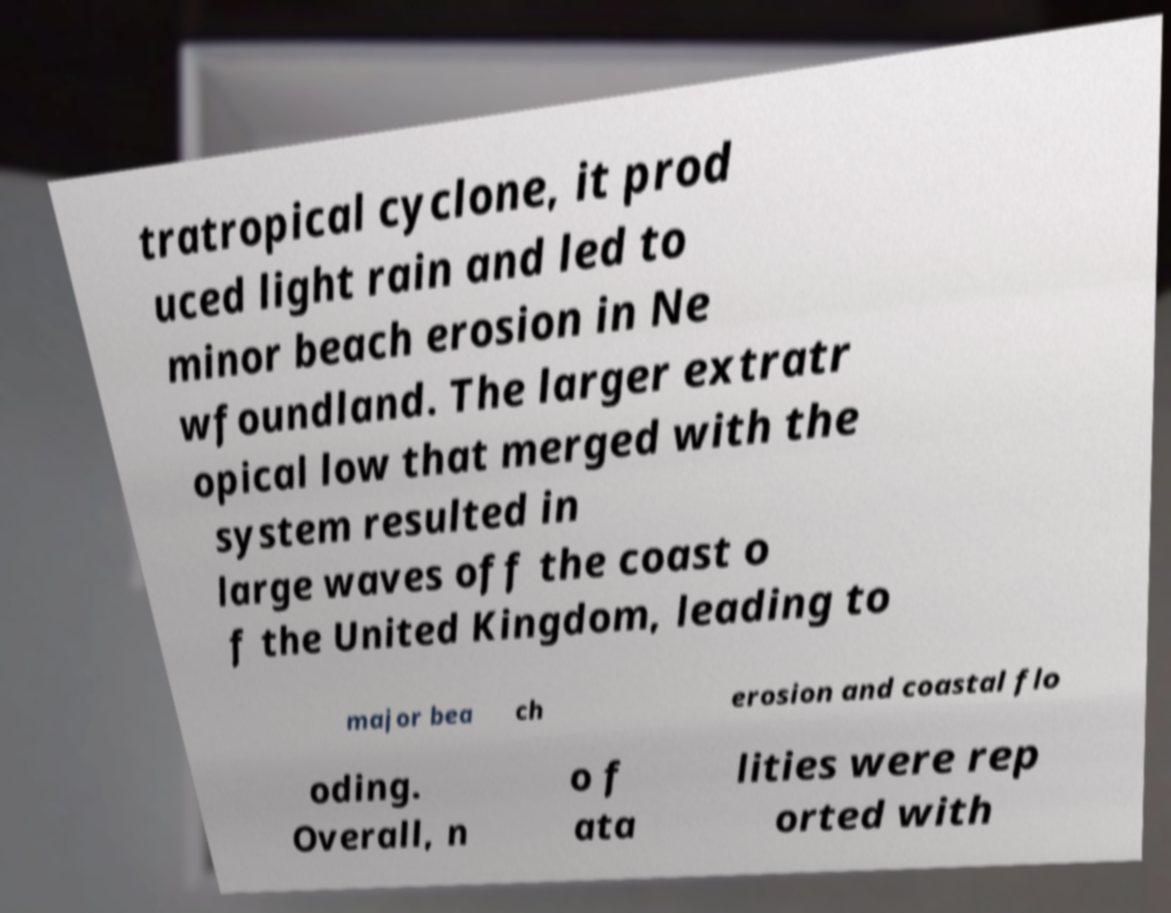Can you accurately transcribe the text from the provided image for me? tratropical cyclone, it prod uced light rain and led to minor beach erosion in Ne wfoundland. The larger extratr opical low that merged with the system resulted in large waves off the coast o f the United Kingdom, leading to major bea ch erosion and coastal flo oding. Overall, n o f ata lities were rep orted with 